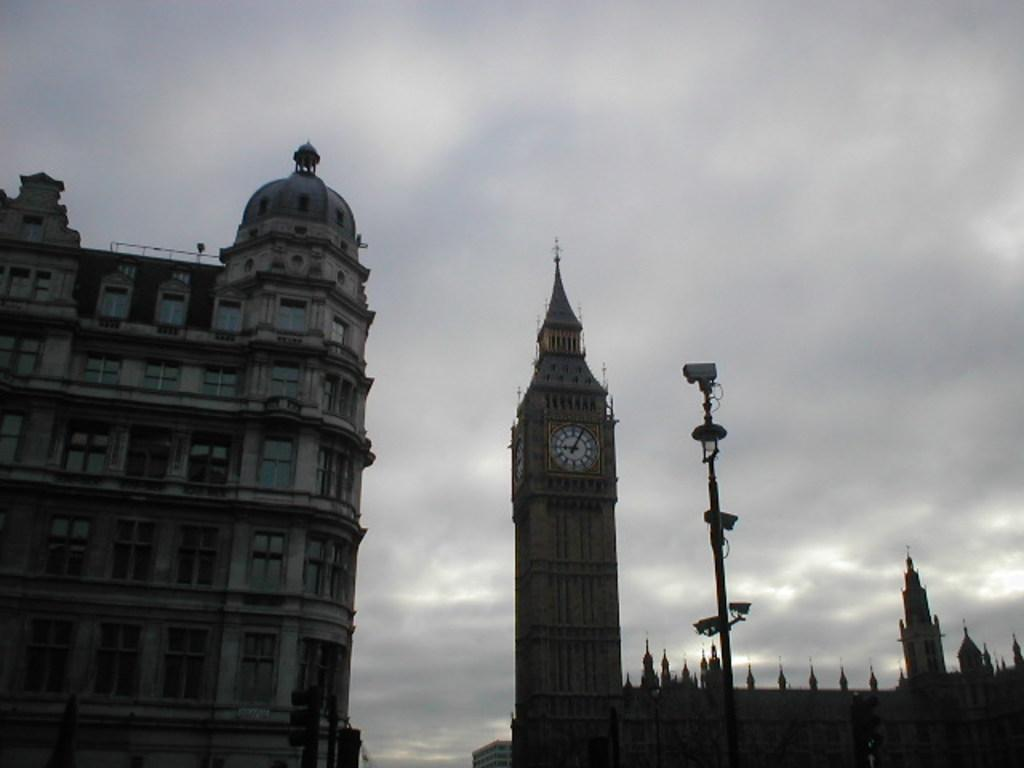What type of structures are visible in the image? There are buildings with windows in the image. What time-related object can be seen in the image? There is a clock in the image. What is attached to the pole in front of the building? There are cameras attached to the pole in front of the building. What can be seen in the background of the image? The sky is visible in the background of the image. Where is the playground located in the image? There is no playground present in the image. What type of powder is being used to make decisions in the image? There is no powder or decision-making process depicted in the image. 